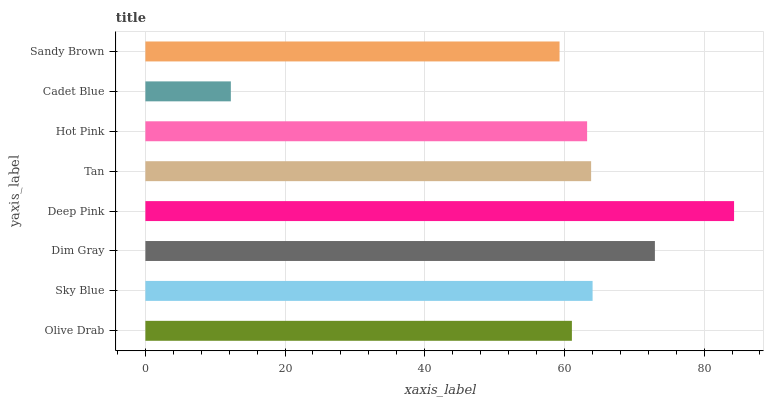Is Cadet Blue the minimum?
Answer yes or no. Yes. Is Deep Pink the maximum?
Answer yes or no. Yes. Is Sky Blue the minimum?
Answer yes or no. No. Is Sky Blue the maximum?
Answer yes or no. No. Is Sky Blue greater than Olive Drab?
Answer yes or no. Yes. Is Olive Drab less than Sky Blue?
Answer yes or no. Yes. Is Olive Drab greater than Sky Blue?
Answer yes or no. No. Is Sky Blue less than Olive Drab?
Answer yes or no. No. Is Tan the high median?
Answer yes or no. Yes. Is Hot Pink the low median?
Answer yes or no. Yes. Is Hot Pink the high median?
Answer yes or no. No. Is Olive Drab the low median?
Answer yes or no. No. 